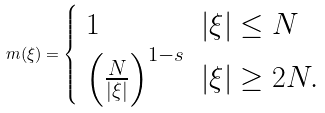<formula> <loc_0><loc_0><loc_500><loc_500>m ( \xi ) = \begin{cases} \begin{array} { l l } 1 & | \xi | \leq N \\ \left ( \frac { N } { | \xi | } \right ) ^ { 1 - s } & | \xi | \geq 2 N . \end{array} \end{cases}</formula> 